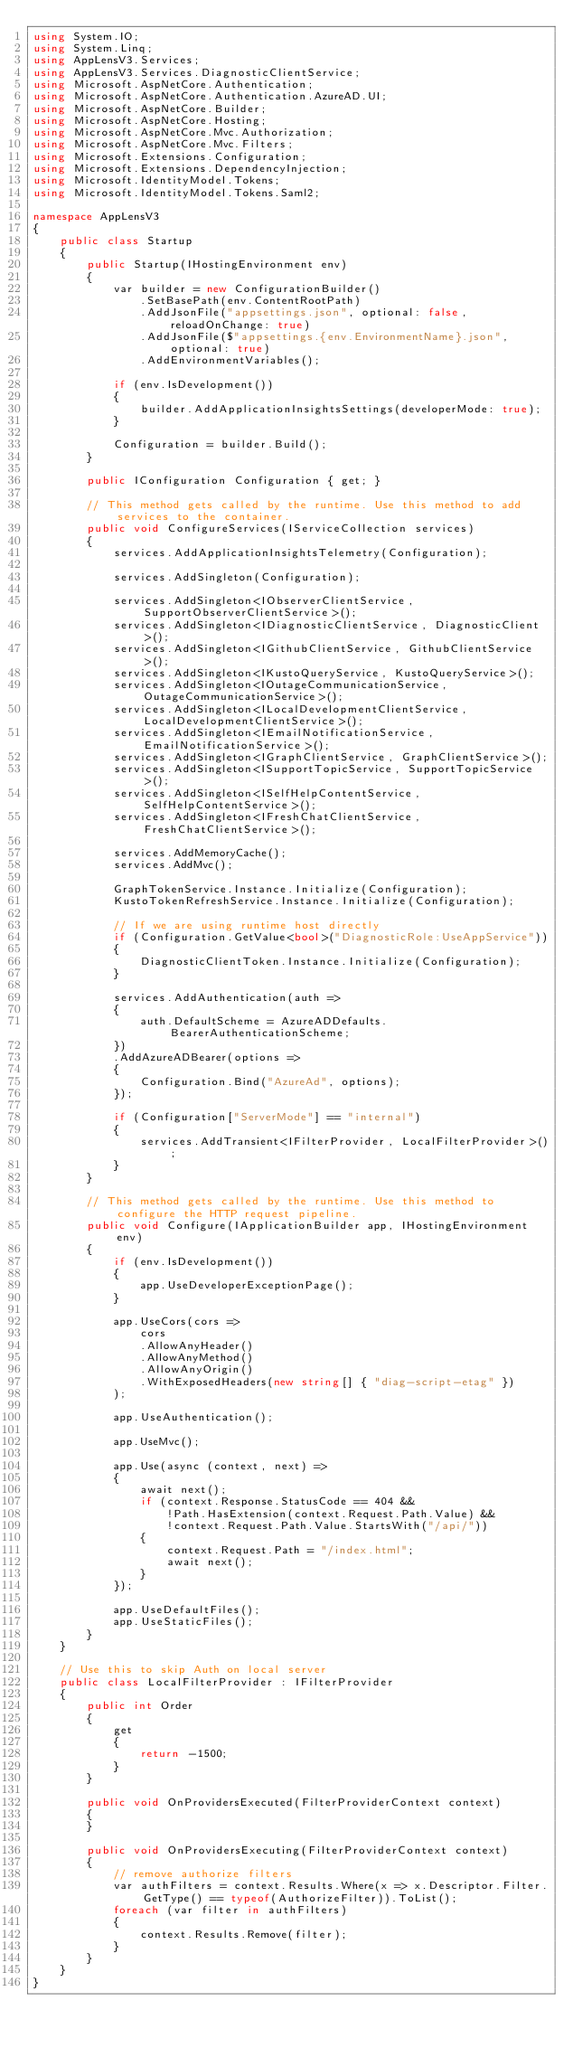<code> <loc_0><loc_0><loc_500><loc_500><_C#_>using System.IO;
using System.Linq;
using AppLensV3.Services;
using AppLensV3.Services.DiagnosticClientService;
using Microsoft.AspNetCore.Authentication;
using Microsoft.AspNetCore.Authentication.AzureAD.UI;
using Microsoft.AspNetCore.Builder;
using Microsoft.AspNetCore.Hosting;
using Microsoft.AspNetCore.Mvc.Authorization;
using Microsoft.AspNetCore.Mvc.Filters;
using Microsoft.Extensions.Configuration;
using Microsoft.Extensions.DependencyInjection;
using Microsoft.IdentityModel.Tokens;
using Microsoft.IdentityModel.Tokens.Saml2;

namespace AppLensV3
{
    public class Startup
    {
        public Startup(IHostingEnvironment env)
        {
            var builder = new ConfigurationBuilder()
                .SetBasePath(env.ContentRootPath)
                .AddJsonFile("appsettings.json", optional: false, reloadOnChange: true)
                .AddJsonFile($"appsettings.{env.EnvironmentName}.json", optional: true)
                .AddEnvironmentVariables();

            if (env.IsDevelopment())
            {
                builder.AddApplicationInsightsSettings(developerMode: true);
            }

            Configuration = builder.Build();
        }

        public IConfiguration Configuration { get; }

        // This method gets called by the runtime. Use this method to add services to the container.
        public void ConfigureServices(IServiceCollection services)
        {
            services.AddApplicationInsightsTelemetry(Configuration);

            services.AddSingleton(Configuration);

            services.AddSingleton<IObserverClientService, SupportObserverClientService>();
            services.AddSingleton<IDiagnosticClientService, DiagnosticClient>();
            services.AddSingleton<IGithubClientService, GithubClientService>();
            services.AddSingleton<IKustoQueryService, KustoQueryService>();
            services.AddSingleton<IOutageCommunicationService, OutageCommunicationService>();
            services.AddSingleton<ILocalDevelopmentClientService, LocalDevelopmentClientService>();
            services.AddSingleton<IEmailNotificationService, EmailNotificationService>();
            services.AddSingleton<IGraphClientService, GraphClientService>();
            services.AddSingleton<ISupportTopicService, SupportTopicService>();
            services.AddSingleton<ISelfHelpContentService, SelfHelpContentService>();
            services.AddSingleton<IFreshChatClientService, FreshChatClientService>();

            services.AddMemoryCache();
            services.AddMvc();

            GraphTokenService.Instance.Initialize(Configuration);
            KustoTokenRefreshService.Instance.Initialize(Configuration);

            // If we are using runtime host directly
            if (Configuration.GetValue<bool>("DiagnosticRole:UseAppService"))
            {
                DiagnosticClientToken.Instance.Initialize(Configuration);
            }

            services.AddAuthentication(auth =>
            {
                auth.DefaultScheme = AzureADDefaults.BearerAuthenticationScheme;
            })
            .AddAzureADBearer(options =>
            {
                Configuration.Bind("AzureAd", options);
            });

            if (Configuration["ServerMode"] == "internal")
            {
                services.AddTransient<IFilterProvider, LocalFilterProvider>();
            }
        }

        // This method gets called by the runtime. Use this method to configure the HTTP request pipeline.
        public void Configure(IApplicationBuilder app, IHostingEnvironment env)
        {
            if (env.IsDevelopment())
            {
                app.UseDeveloperExceptionPage();
            }

            app.UseCors(cors =>
                cors
                .AllowAnyHeader()
                .AllowAnyMethod()
                .AllowAnyOrigin()
                .WithExposedHeaders(new string[] { "diag-script-etag" })
            );

            app.UseAuthentication();

            app.UseMvc();

            app.Use(async (context, next) =>
            {
                await next();
                if (context.Response.StatusCode == 404 &&
                    !Path.HasExtension(context.Request.Path.Value) &&
                    !context.Request.Path.Value.StartsWith("/api/"))
                {
                    context.Request.Path = "/index.html";
                    await next();
                }
            });

            app.UseDefaultFiles();
            app.UseStaticFiles();
        }
    }

    // Use this to skip Auth on local server
    public class LocalFilterProvider : IFilterProvider
    {
        public int Order
        {
            get
            {
                return -1500;
            }
        }

        public void OnProvidersExecuted(FilterProviderContext context)
        {
        }

        public void OnProvidersExecuting(FilterProviderContext context)
        {
            // remove authorize filters
            var authFilters = context.Results.Where(x => x.Descriptor.Filter.GetType() == typeof(AuthorizeFilter)).ToList();
            foreach (var filter in authFilters)
            {
                context.Results.Remove(filter);
            }
        }
    }
}</code> 